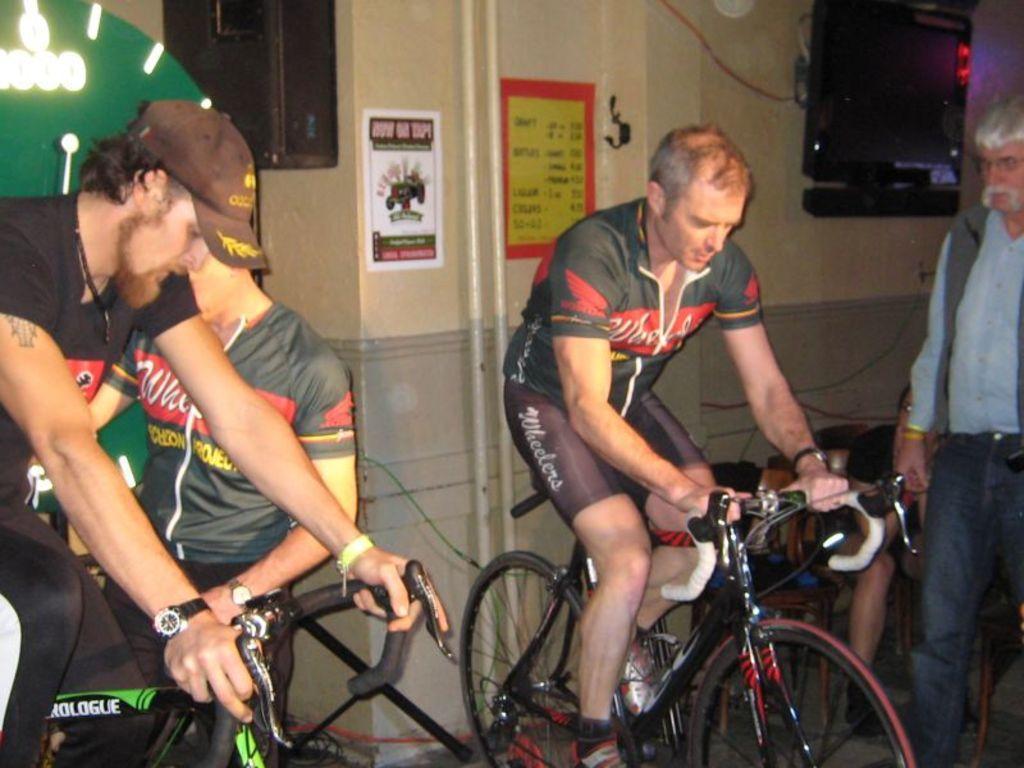How would you summarize this image in a sentence or two? This is the picture taken in a room, there are two persons are riding their bicycles and other two persons are standing on the floor. Behind the people there is a wall on the wall there are posters and a television. 